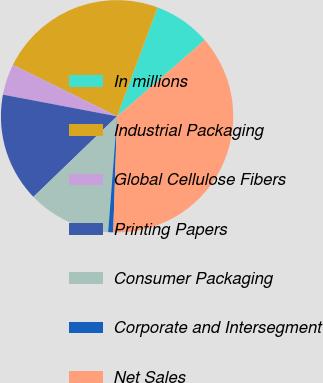Convert chart to OTSL. <chart><loc_0><loc_0><loc_500><loc_500><pie_chart><fcel>In millions<fcel>Industrial Packaging<fcel>Global Cellulose Fibers<fcel>Printing Papers<fcel>Consumer Packaging<fcel>Corporate and Intersegment<fcel>Net Sales<nl><fcel>7.95%<fcel>23.36%<fcel>4.32%<fcel>15.19%<fcel>11.57%<fcel>0.7%<fcel>36.91%<nl></chart> 